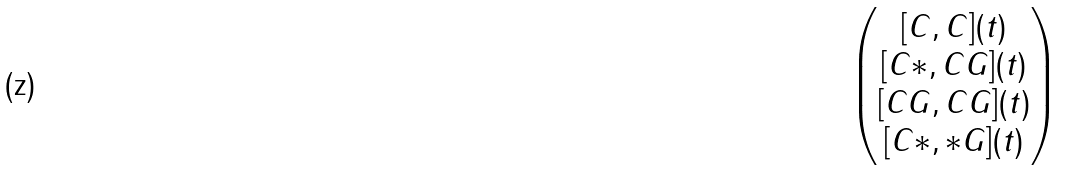<formula> <loc_0><loc_0><loc_500><loc_500>\begin{pmatrix} [ C , C ] ( t ) \\ [ C * , C G ] ( t ) \\ [ C G , C G ] ( t ) \\ [ C * , * G ] ( t ) \end{pmatrix}</formula> 